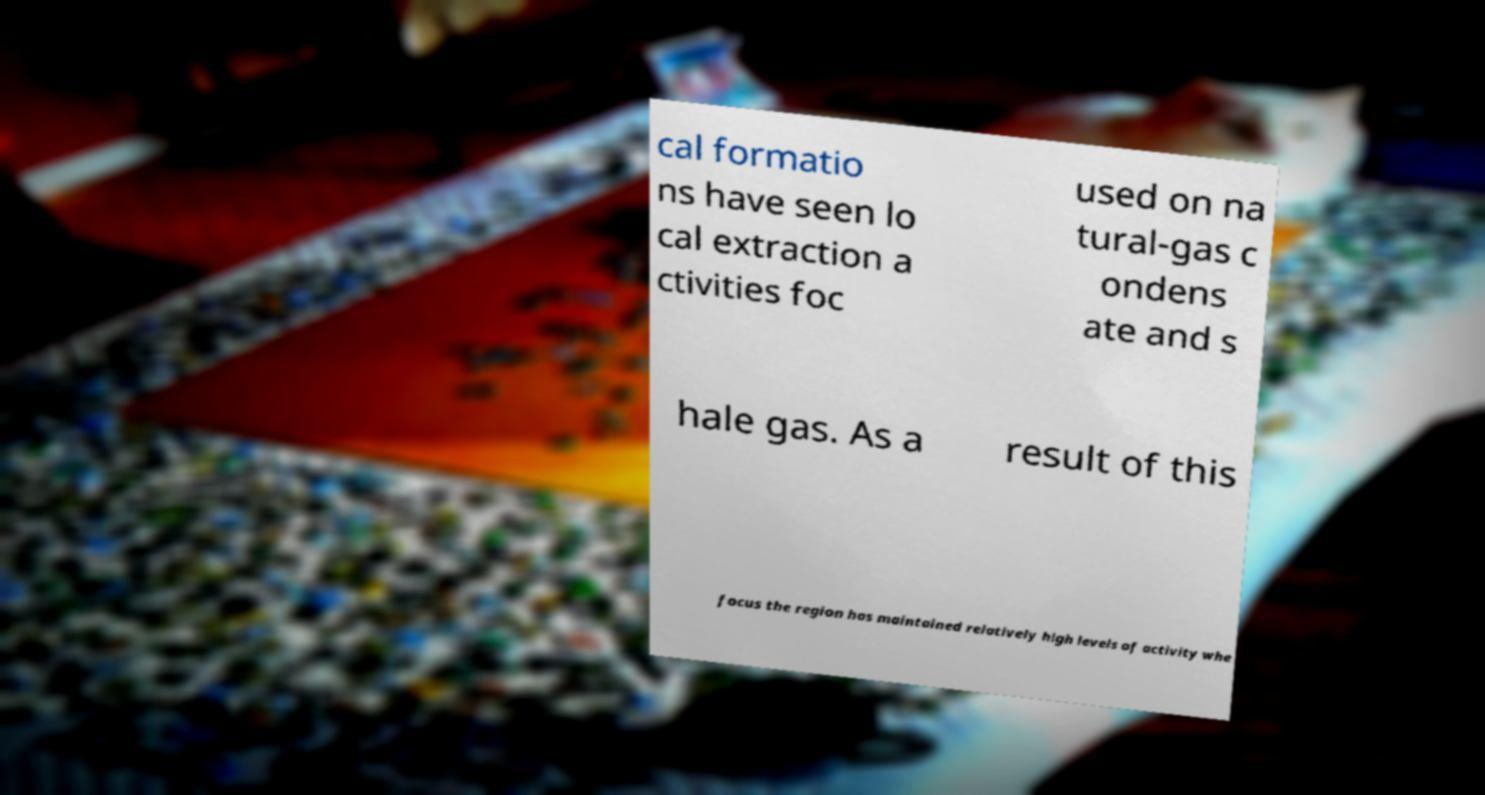What messages or text are displayed in this image? I need them in a readable, typed format. cal formatio ns have seen lo cal extraction a ctivities foc used on na tural-gas c ondens ate and s hale gas. As a result of this focus the region has maintained relatively high levels of activity whe 